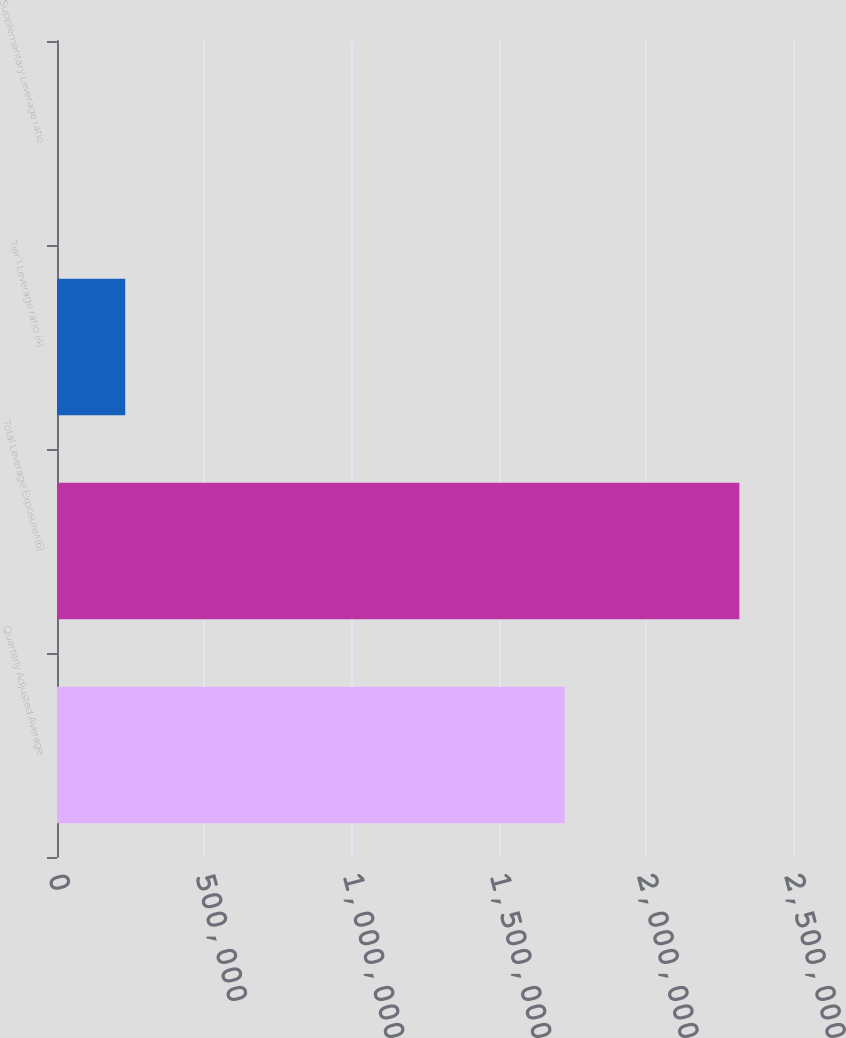Convert chart to OTSL. <chart><loc_0><loc_0><loc_500><loc_500><bar_chart><fcel>Quarterly Adjusted Average<fcel>Total Leverage Exposure^(6)<fcel>Tier 1 Leverage ratio (4)<fcel>Supplementary Leverage ratio<nl><fcel>1.72471e+06<fcel>2.31785e+06<fcel>231791<fcel>7.08<nl></chart> 